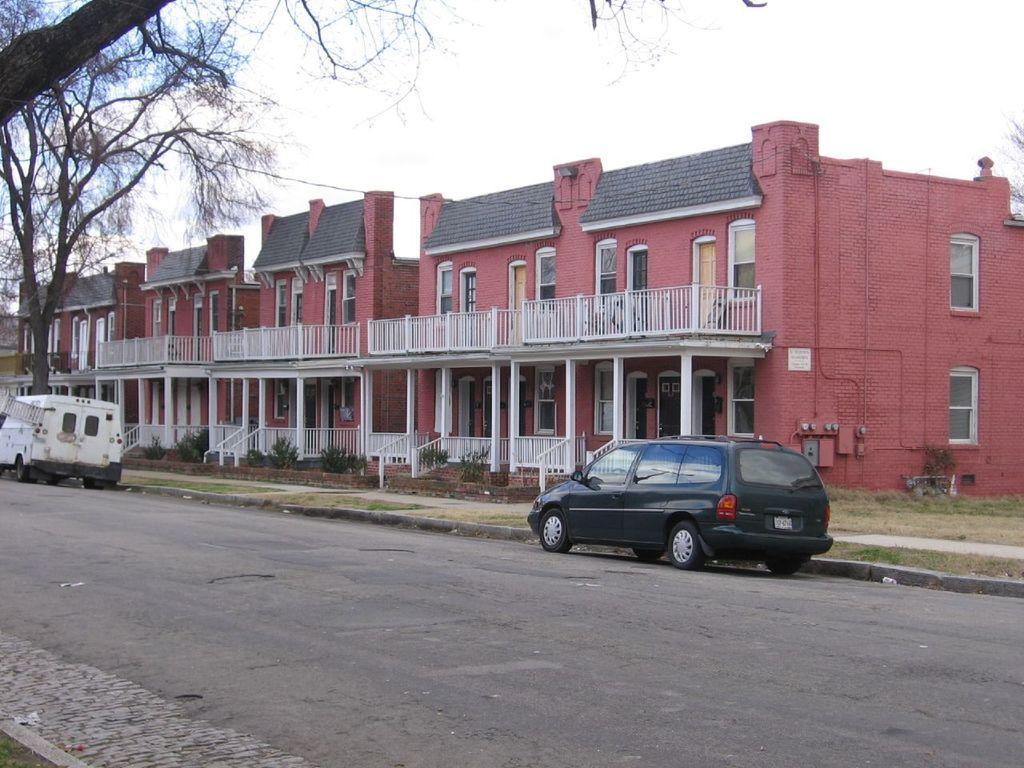How would you summarize this image in a sentence or two? In this image I can see some vehicles on the road. I can see the trees. On the right side, I can see the buildings. At the top I can see the sky. 